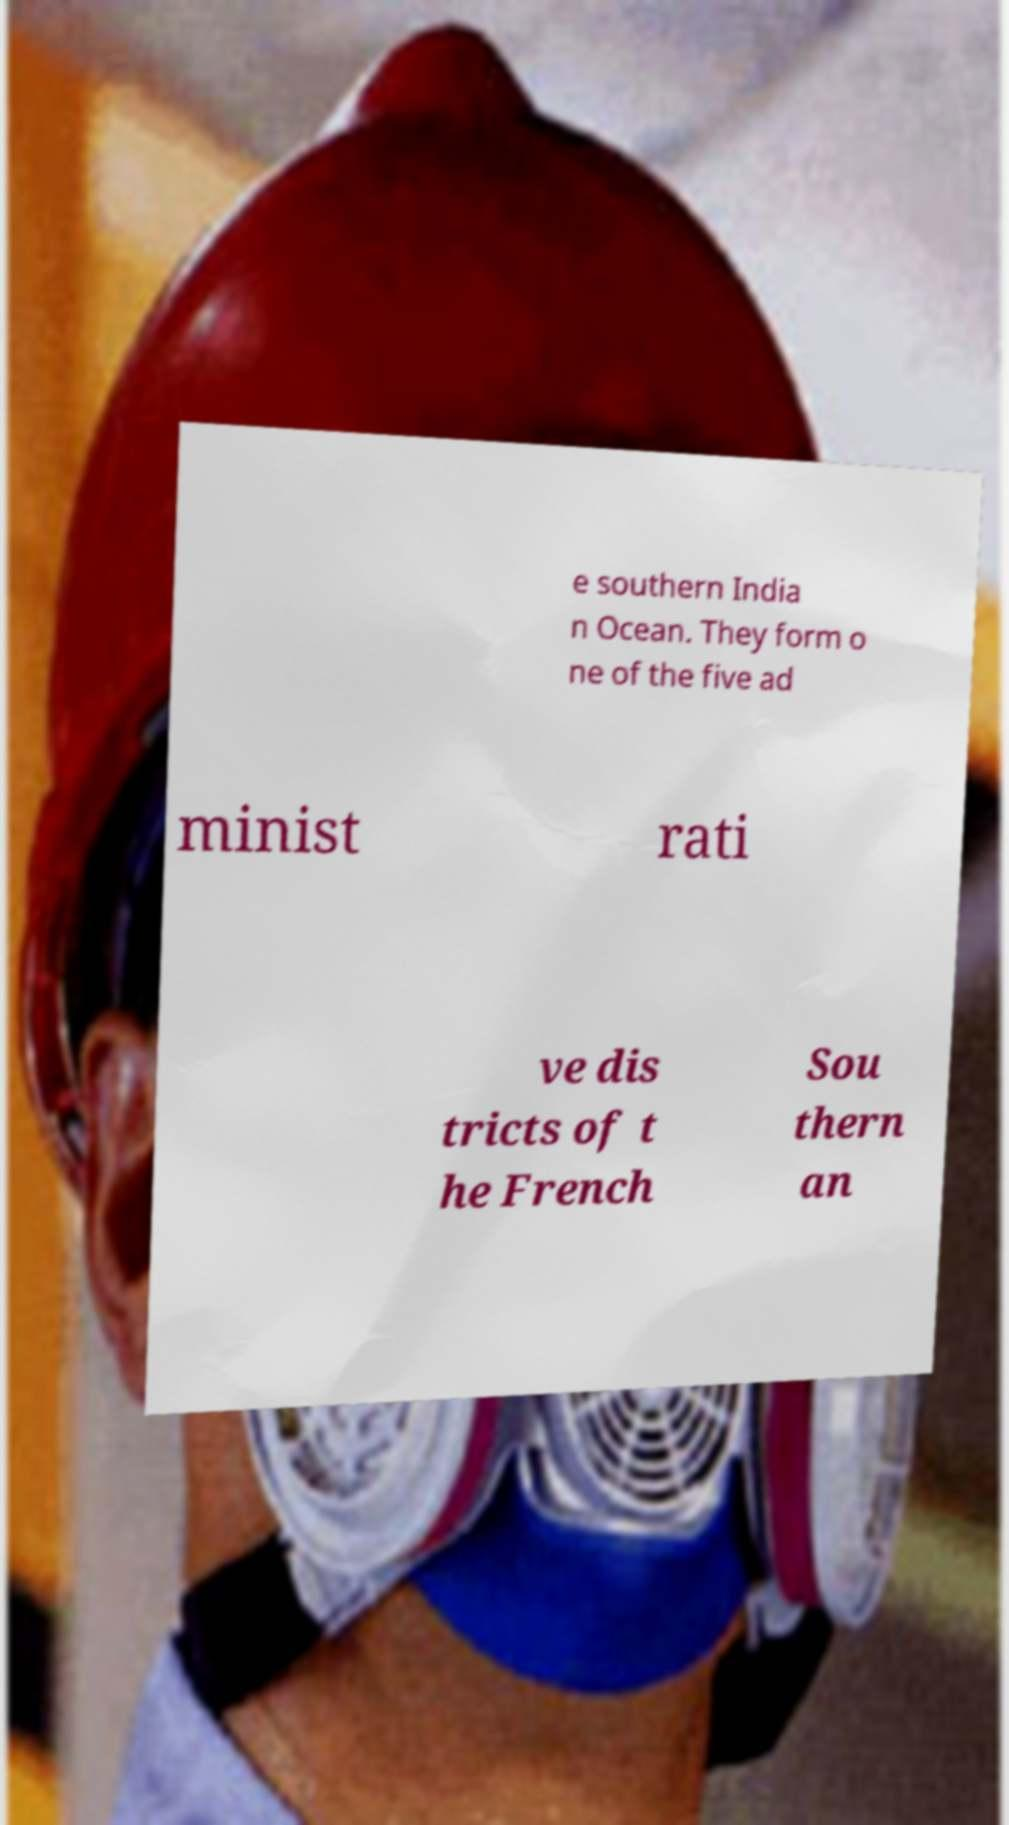Can you read and provide the text displayed in the image?This photo seems to have some interesting text. Can you extract and type it out for me? e southern India n Ocean. They form o ne of the five ad minist rati ve dis tricts of t he French Sou thern an 